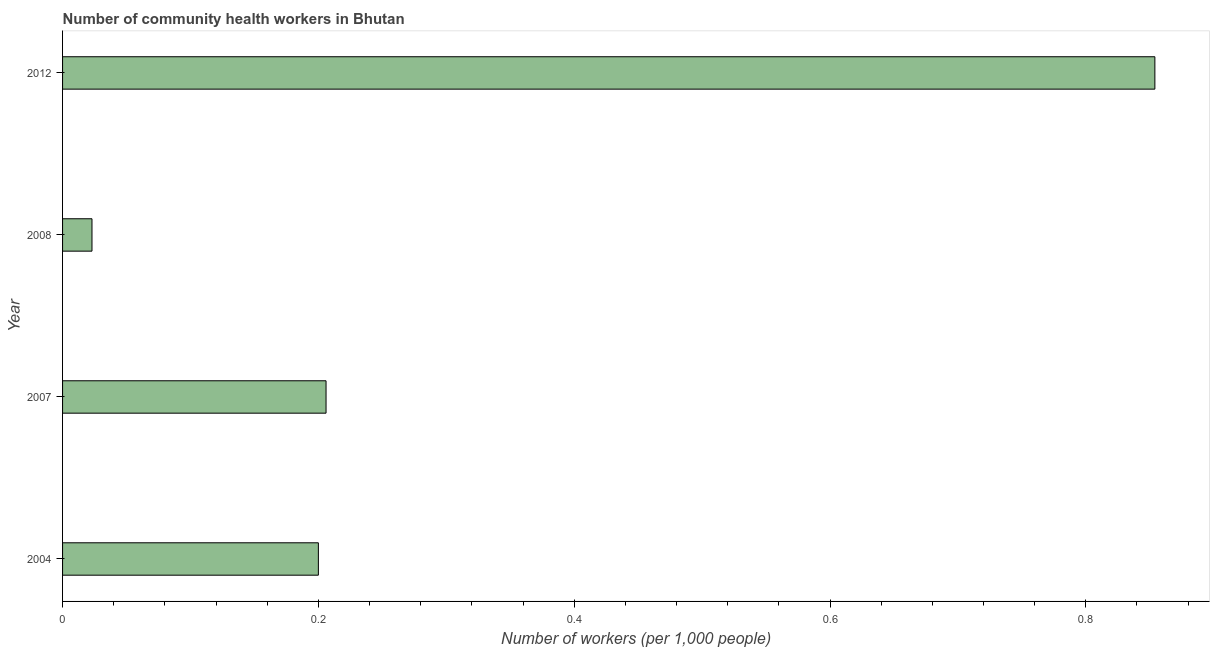Does the graph contain any zero values?
Offer a very short reply. No. Does the graph contain grids?
Keep it short and to the point. No. What is the title of the graph?
Your answer should be very brief. Number of community health workers in Bhutan. What is the label or title of the X-axis?
Give a very brief answer. Number of workers (per 1,0 people). Across all years, what is the maximum number of community health workers?
Provide a short and direct response. 0.85. Across all years, what is the minimum number of community health workers?
Your answer should be compact. 0.02. In which year was the number of community health workers maximum?
Give a very brief answer. 2012. What is the sum of the number of community health workers?
Ensure brevity in your answer.  1.28. What is the difference between the number of community health workers in 2007 and 2008?
Give a very brief answer. 0.18. What is the average number of community health workers per year?
Offer a very short reply. 0.32. What is the median number of community health workers?
Offer a very short reply. 0.2. In how many years, is the number of community health workers greater than 0.64 ?
Your answer should be compact. 1. Do a majority of the years between 2007 and 2012 (inclusive) have number of community health workers greater than 0.32 ?
Provide a short and direct response. No. What is the ratio of the number of community health workers in 2007 to that in 2012?
Provide a short and direct response. 0.24. What is the difference between the highest and the second highest number of community health workers?
Give a very brief answer. 0.65. Is the sum of the number of community health workers in 2004 and 2007 greater than the maximum number of community health workers across all years?
Ensure brevity in your answer.  No. What is the difference between the highest and the lowest number of community health workers?
Your answer should be compact. 0.83. Are all the bars in the graph horizontal?
Your answer should be compact. Yes. Are the values on the major ticks of X-axis written in scientific E-notation?
Give a very brief answer. No. What is the Number of workers (per 1,000 people) of 2004?
Your answer should be compact. 0.2. What is the Number of workers (per 1,000 people) of 2007?
Provide a succinct answer. 0.21. What is the Number of workers (per 1,000 people) in 2008?
Offer a very short reply. 0.02. What is the Number of workers (per 1,000 people) in 2012?
Ensure brevity in your answer.  0.85. What is the difference between the Number of workers (per 1,000 people) in 2004 and 2007?
Provide a succinct answer. -0.01. What is the difference between the Number of workers (per 1,000 people) in 2004 and 2008?
Provide a succinct answer. 0.18. What is the difference between the Number of workers (per 1,000 people) in 2004 and 2012?
Your response must be concise. -0.65. What is the difference between the Number of workers (per 1,000 people) in 2007 and 2008?
Make the answer very short. 0.18. What is the difference between the Number of workers (per 1,000 people) in 2007 and 2012?
Give a very brief answer. -0.65. What is the difference between the Number of workers (per 1,000 people) in 2008 and 2012?
Offer a terse response. -0.83. What is the ratio of the Number of workers (per 1,000 people) in 2004 to that in 2008?
Provide a succinct answer. 8.7. What is the ratio of the Number of workers (per 1,000 people) in 2004 to that in 2012?
Your answer should be compact. 0.23. What is the ratio of the Number of workers (per 1,000 people) in 2007 to that in 2008?
Your response must be concise. 8.96. What is the ratio of the Number of workers (per 1,000 people) in 2007 to that in 2012?
Your response must be concise. 0.24. What is the ratio of the Number of workers (per 1,000 people) in 2008 to that in 2012?
Provide a succinct answer. 0.03. 